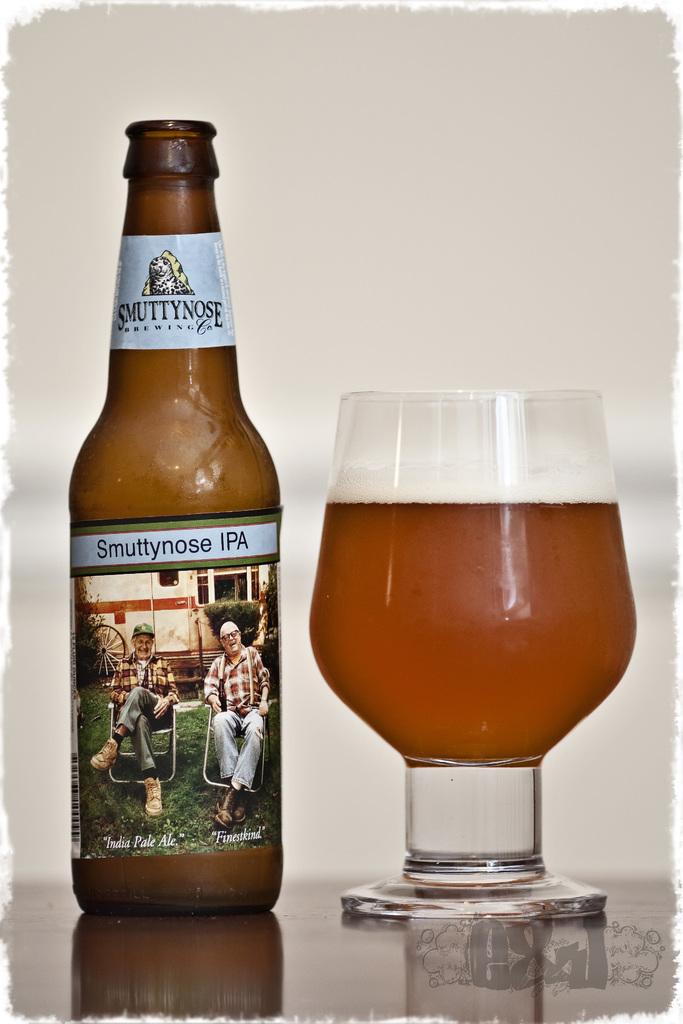What is the brand of this drink?
Give a very brief answer. Smuttynose. What three letters are next to the word smuttynose?
Offer a very short reply. Ipa. 